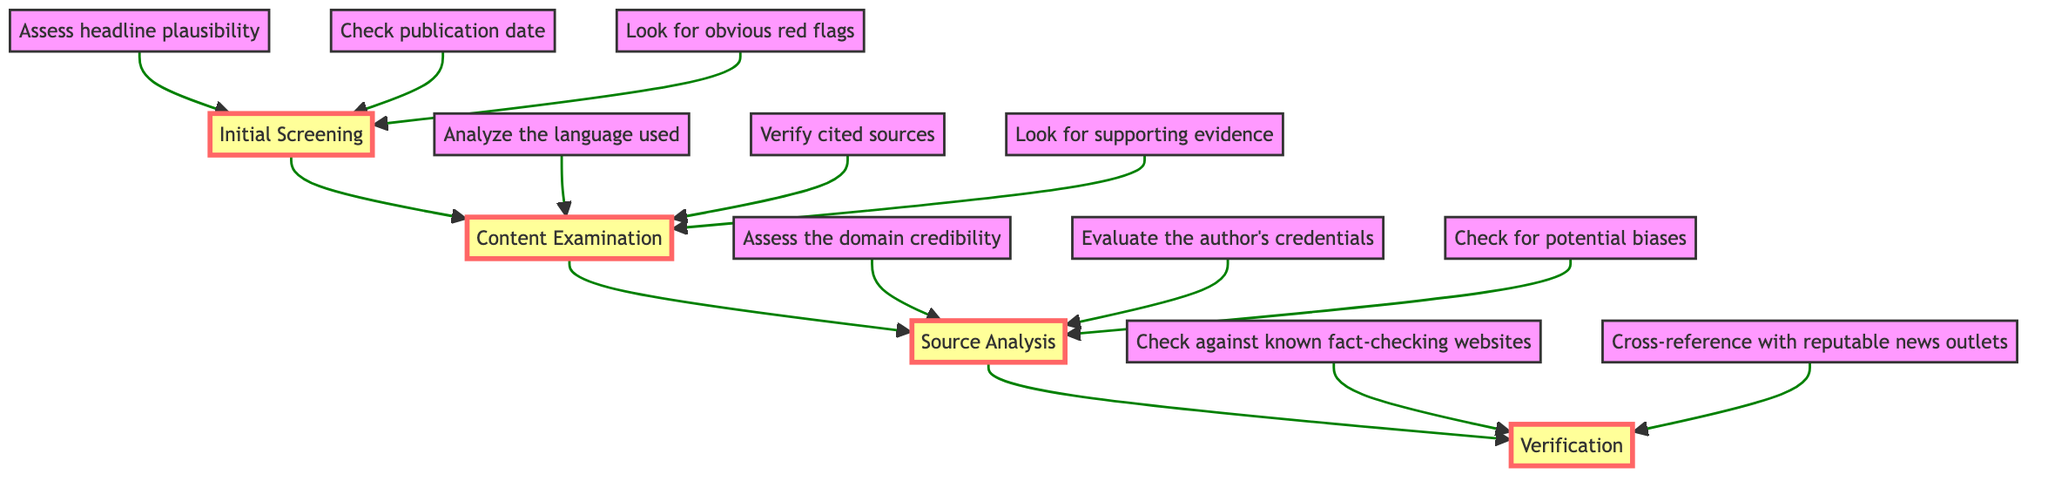what is the first step in the flowchart? The first step is represented by the node "Initial Screening," which is at the bottom of the flowchart and indicates the starting point for evaluating news credibility.
Answer: Initial Screening how many main stages are there in the flowchart? The flowchart consists of four main stages, represented by the nodes: Initial Screening, Content Examination, Source Analysis, and Verification, leading upward through the flow chart.
Answer: Four what does the Content Examination step analyze? The Content Examination step analyzes three aspects: the language used, cited sources, and supporting evidence, as listed in the content of that node.
Answer: Language used, cited sources, supporting evidence which nodes provide checks for verification? The Verification node provides two checks for verifying news credibility: checking against known fact-checking websites and cross-referencing with reputable news outlets, which are listed under that node.
Answer: Check against known fact-checking websites, cross-reference with reputable news outlets what types of content are assessed in the Source Analysis stage? In the Source Analysis stage, three types of content are assessed: the domain credibility, the author's credentials, and potential biases, which help evaluate the source's reliability.
Answer: Domain credibility, author's credentials, potential biases how does the flow between Initial Screening and Verification occur? The flow from Initial Screening to Verification occurs sequentially through the nodes, meaning the process must pass through Content Examination and Source Analysis before reaching Verification at the top of the flowchart.
Answer: Sequentially through Content Examination, Source Analysis which checks for obvious red flags are included in the Initial Screening? The Initial Screening includes checks for three specific obvious red flags: headline plausibility, publication date, and visible errors like spelling and grammar mistakes, which are listed under that node.
Answer: Headline plausibility, publication date, obvious red flags what is the criteria listed under the Initial Screening for evaluating headlines? The criterion listed under the Initial Screening for evaluating headlines states to assess their plausibility, particularly looking out for headlines that could be too sensational or categorized as clickbait.
Answer: Assess headline plausibility how many content items are examined in the Content Examination step? The Content Examination step examines three content items: language analysis, verification of cited sources, and checking for supporting evidence, which are crucial for credibility assessment.
Answer: Three 